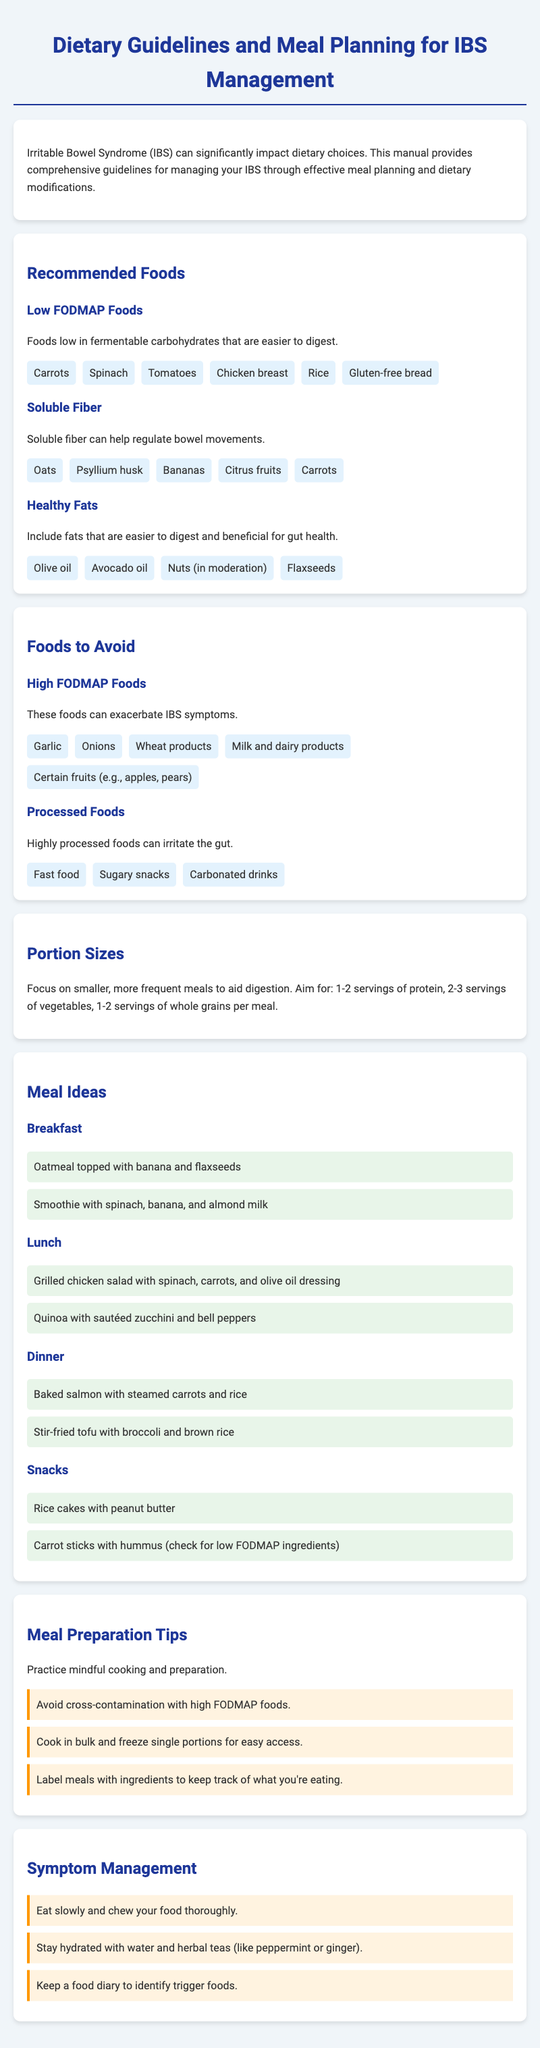what are low FODMAP foods? Low FODMAP foods are those that are low in fermentable carbohydrates and easier to digest.
Answer: Carrots, Spinach, Tomatoes, Chicken breast, Rice, Gluten-free bread what type of fiber helps regulate bowel movements? Soluble fiber can help regulate bowel movements.
Answer: Soluble fiber what is recommended to avoid during meal preparation? You should avoid cross-contamination with high FODMAP foods during meal preparation.
Answer: Cross-contamination how many servings of protein are recommended per meal? The recommendations suggest 1-2 servings of protein per meal for better digestion.
Answer: 1-2 servings what should you eat slowly and chew thoroughly? Eating slowly and chewing thoroughly helps with symptom management.
Answer: Food what is the purpose of a food diary? A food diary is kept to identify trigger foods that may exacerbate symptoms.
Answer: Identify trigger foods which type of oils are considered healthy fats? Olive oil, avocado oil, and flaxseeds are considered healthy fats.
Answer: Olive oil, avocado oil, nuts, flaxseeds which meal idea includes oatmeal? The breakfast meal idea includes oatmeal topped with banana and flaxseeds.
Answer: Oatmeal topped with banana and flaxseeds what should you stay hydrated with? Staying hydrated with water and herbal teas is advised for symptom management.
Answer: Water and herbal teas 